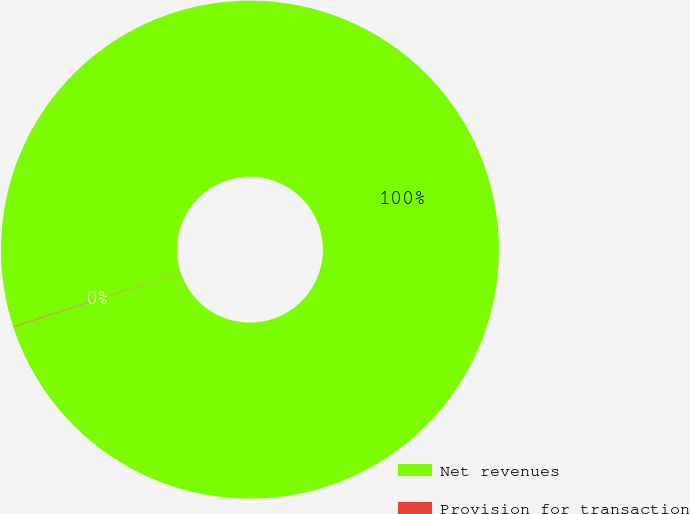Convert chart. <chart><loc_0><loc_0><loc_500><loc_500><pie_chart><fcel>Net revenues<fcel>Provision for transaction<nl><fcel>99.96%<fcel>0.04%<nl></chart> 